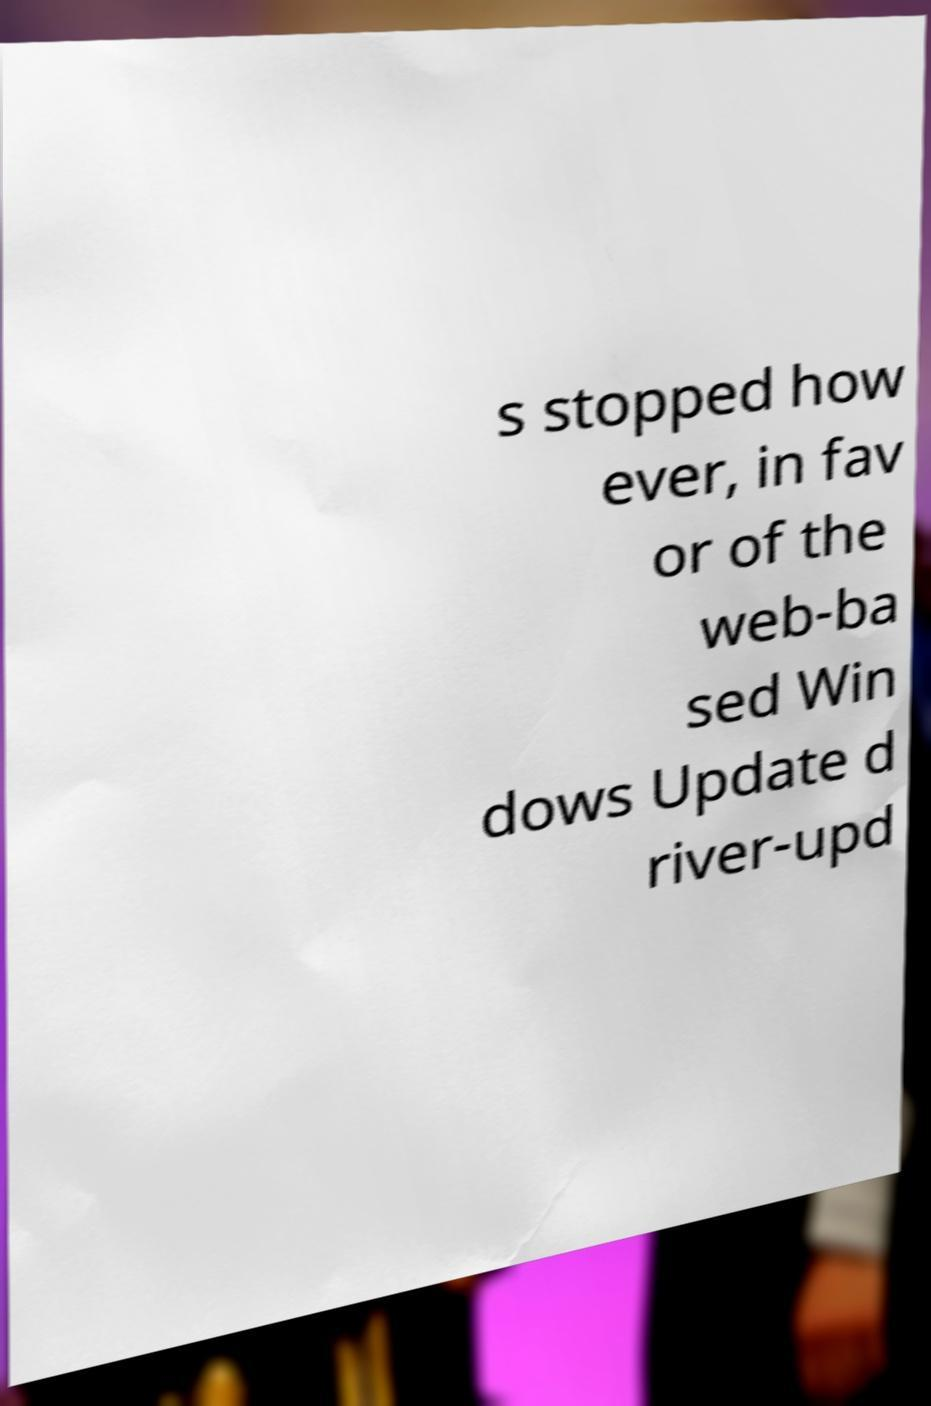For documentation purposes, I need the text within this image transcribed. Could you provide that? s stopped how ever, in fav or of the web-ba sed Win dows Update d river-upd 